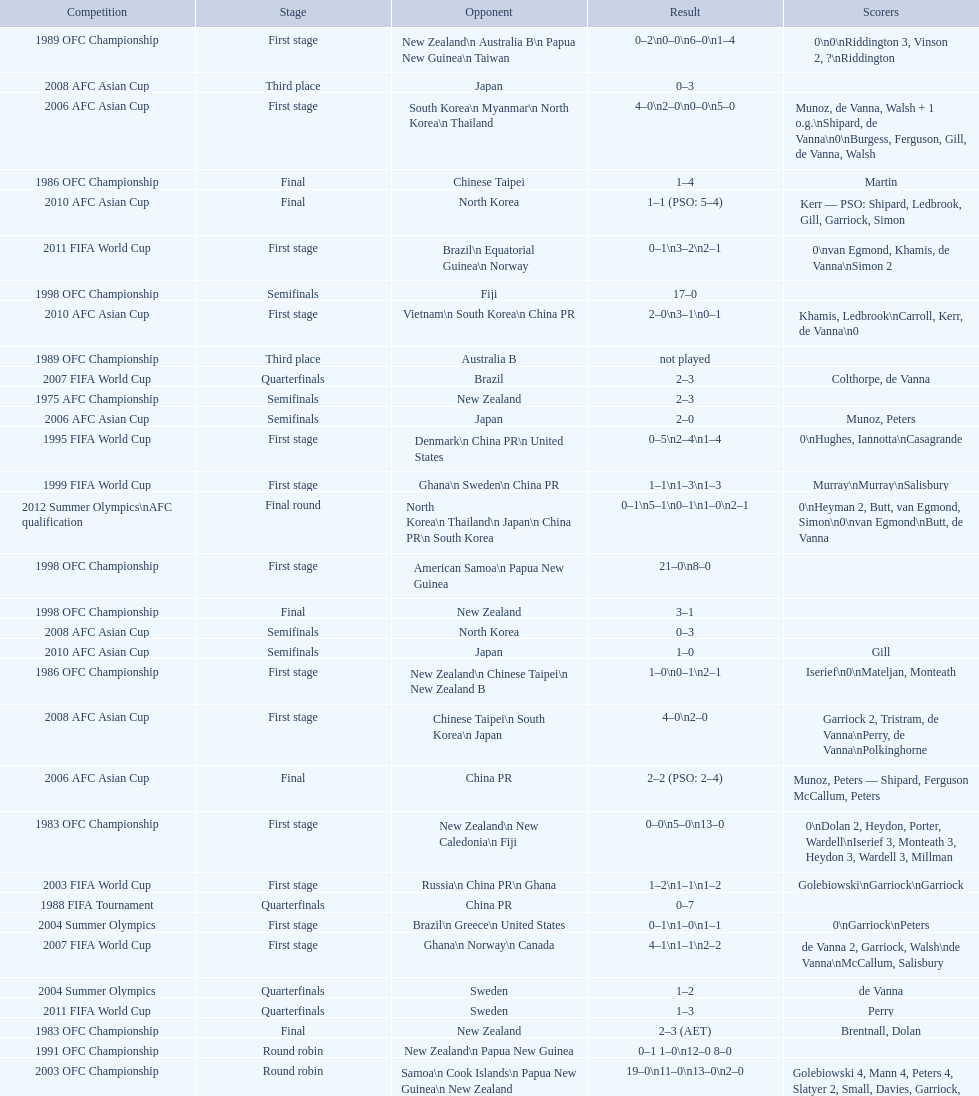Who was this team's next opponent after facing new zealand in the first stage of the 1986 ofc championship? Chinese Taipei. 